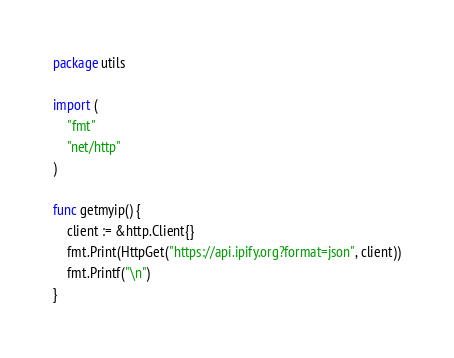<code> <loc_0><loc_0><loc_500><loc_500><_Go_>package utils

import (
	"fmt"
	"net/http"
)

func getmyip() {
	client := &http.Client{}
	fmt.Print(HttpGet("https://api.ipify.org?format=json", client))
	fmt.Printf("\n")
}
</code> 